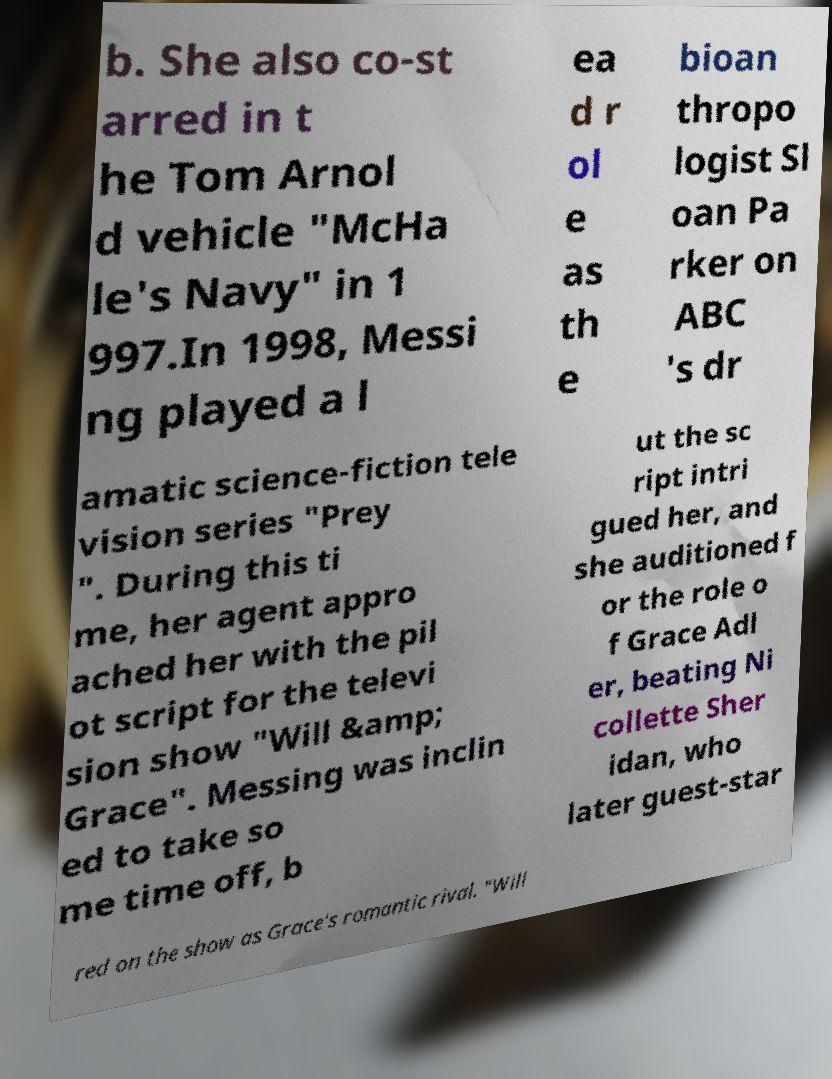I need the written content from this picture converted into text. Can you do that? b. She also co-st arred in t he Tom Arnol d vehicle "McHa le's Navy" in 1 997.In 1998, Messi ng played a l ea d r ol e as th e bioan thropo logist Sl oan Pa rker on ABC 's dr amatic science-fiction tele vision series "Prey ". During this ti me, her agent appro ached her with the pil ot script for the televi sion show "Will &amp; Grace". Messing was inclin ed to take so me time off, b ut the sc ript intri gued her, and she auditioned f or the role o f Grace Adl er, beating Ni collette Sher idan, who later guest-star red on the show as Grace's romantic rival. "Will 